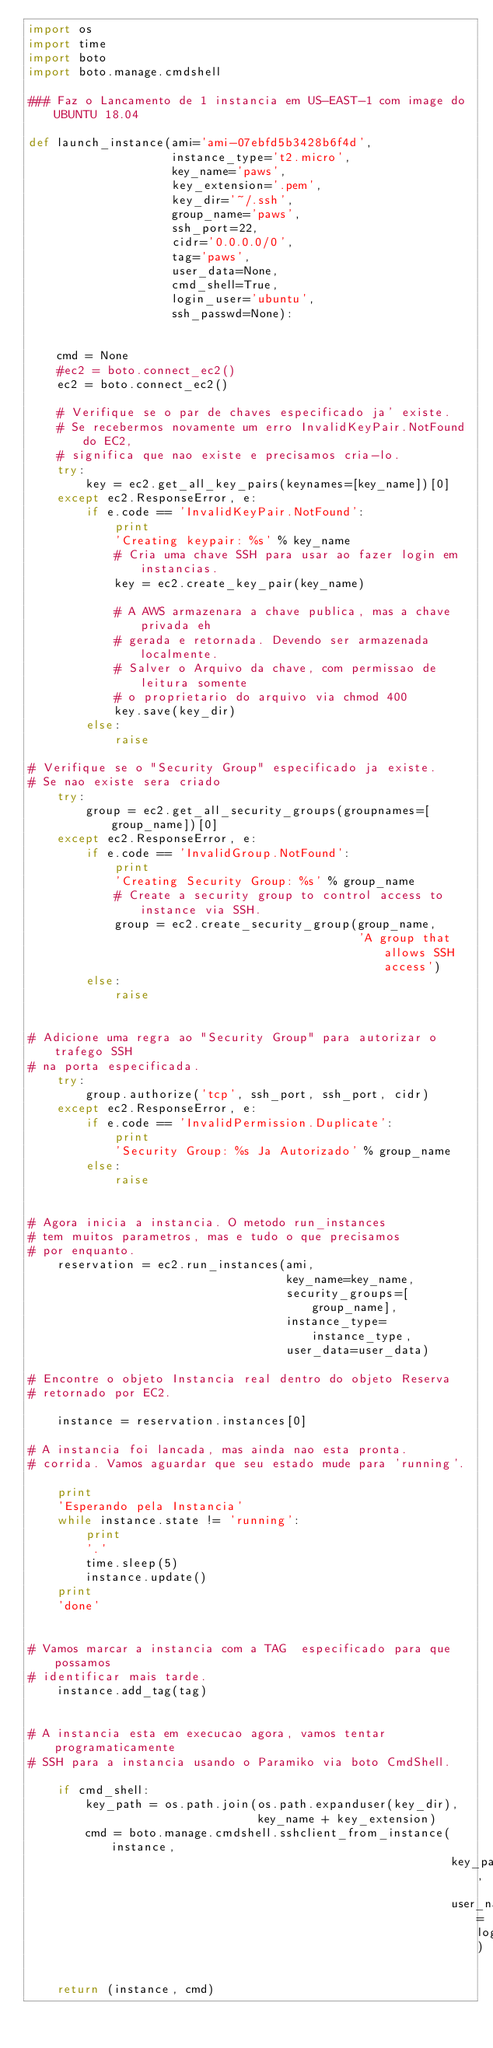<code> <loc_0><loc_0><loc_500><loc_500><_Python_>import os
import time
import boto
import boto.manage.cmdshell

### Faz o Lancamento de 1 instancia em US-EAST-1 com image do UBUNTU 18.04

def launch_instance(ami='ami-07ebfd5b3428b6f4d',
                    instance_type='t2.micro',
                    key_name='paws',
                    key_extension='.pem',
                    key_dir='~/.ssh',
                    group_name='paws',
                    ssh_port=22,
                    cidr='0.0.0.0/0',
                    tag='paws',
                    user_data=None,
                    cmd_shell=True,
                    login_user='ubuntu',
                    ssh_passwd=None):


    cmd = None
    #ec2 = boto.connect_ec2()
    ec2 = boto.connect_ec2()

    # Verifique se o par de chaves especificado ja' existe.
    # Se recebermos novamente um erro InvalidKeyPair.NotFound do EC2,
    # significa que nao existe e precisamos cria-lo.
    try:
        key = ec2.get_all_key_pairs(keynames=[key_name])[0]
    except ec2.ResponseError, e:
        if e.code == 'InvalidKeyPair.NotFound':
            print
            'Creating keypair: %s' % key_name
            # Cria uma chave SSH para usar ao fazer login em instancias.
            key = ec2.create_key_pair(key_name)

            # A AWS armazenara a chave publica, mas a chave privada eh
            # gerada e retornada. Devendo ser armazenada localmente.
            # Salver o Arquivo da chave, com permissao de leitura somente
            # o proprietario do arquivo via chmod 400
            key.save(key_dir)
        else:
            raise

# Verifique se o "Security Group" especificado ja existe.
# Se nao existe sera criado
    try:
        group = ec2.get_all_security_groups(groupnames=[group_name])[0]
    except ec2.ResponseError, e:
        if e.code == 'InvalidGroup.NotFound':
            print
            'Creating Security Group: %s' % group_name
            # Create a security group to control access to instance via SSH.
            group = ec2.create_security_group(group_name,
                                              'A group that allows SSH access')
        else:
            raise


# Adicione uma regra ao "Security Group" para autorizar o trafego SSH
# na porta especificada.
    try:
        group.authorize('tcp', ssh_port, ssh_port, cidr)
    except ec2.ResponseError, e:
        if e.code == 'InvalidPermission.Duplicate':
            print
            'Security Group: %s Ja Autorizado' % group_name
        else:
            raise


# Agora inicia a instancia. O metodo run_instances
# tem muitos parametros, mas e tudo o que precisamos
# por enquanto.
    reservation = ec2.run_instances(ami,
                                    key_name=key_name,
                                    security_groups=[group_name],
                                    instance_type=instance_type,
                                    user_data=user_data)

# Encontre o objeto Instancia real dentro do objeto Reserva
# retornado por EC2.

    instance = reservation.instances[0]

# A instancia foi lancada, mas ainda nao esta pronta.
# corrida. Vamos aguardar que seu estado mude para 'running'.

    print
    'Esperando pela Instancia'
    while instance.state != 'running':
        print
        '.'
        time.sleep(5)
        instance.update()
    print
    'done'


# Vamos marcar a instancia com a TAG  especificado para que possamos
# identificar mais tarde.
    instance.add_tag(tag)


# A instancia esta em execucao agora, vamos tentar programaticamente
# SSH para a instancia usando o Paramiko via boto CmdShell.

    if cmd_shell:
        key_path = os.path.join(os.path.expanduser(key_dir),
                                key_name + key_extension)
        cmd = boto.manage.cmdshell.sshclient_from_instance(instance,
                                                           key_path,
                                                           user_name=login_user)

    return (instance, cmd)</code> 